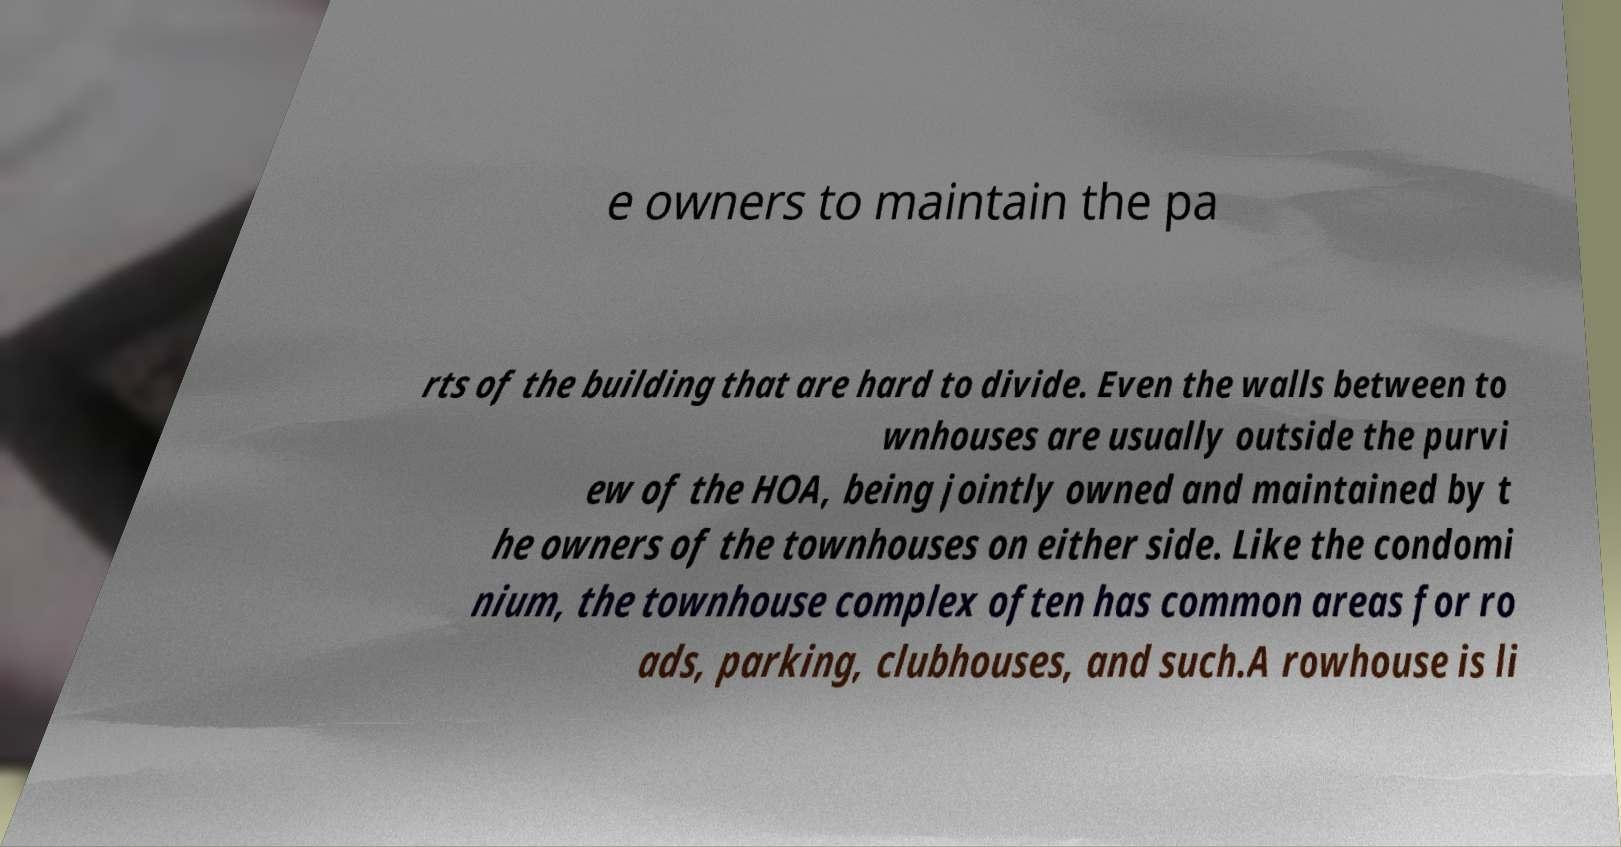Can you read and provide the text displayed in the image?This photo seems to have some interesting text. Can you extract and type it out for me? e owners to maintain the pa rts of the building that are hard to divide. Even the walls between to wnhouses are usually outside the purvi ew of the HOA, being jointly owned and maintained by t he owners of the townhouses on either side. Like the condomi nium, the townhouse complex often has common areas for ro ads, parking, clubhouses, and such.A rowhouse is li 